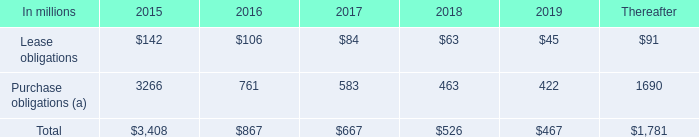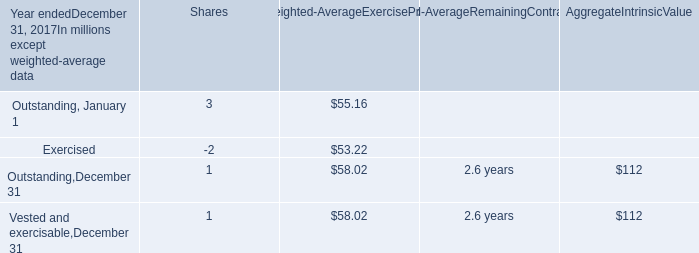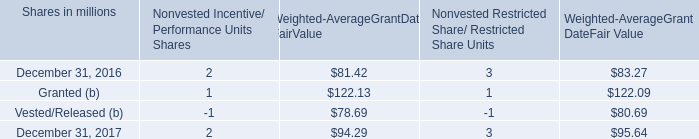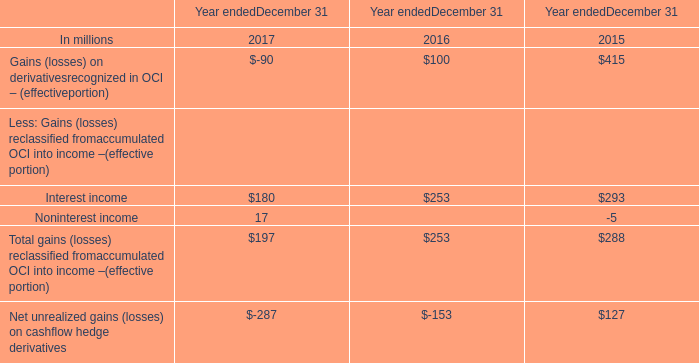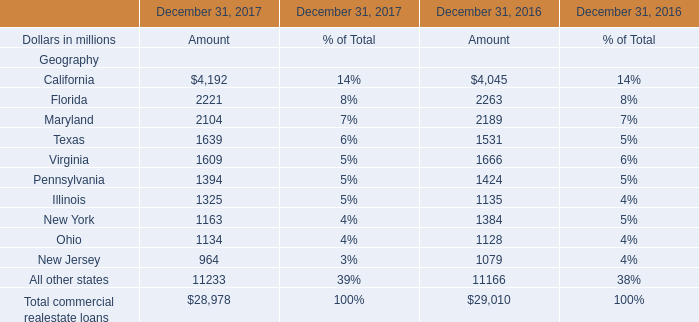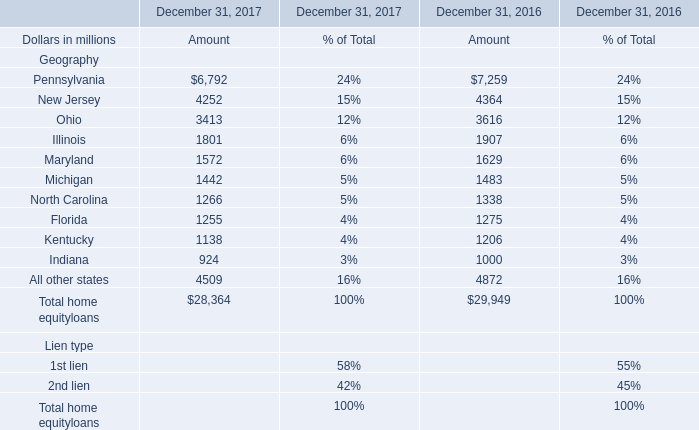What is the proportion of all home equity loans that are greater than 3000 to the total amount of home equity loans, in 2017? (in %) 
Computations: ((((6792 + 4252) + 3413) + 4509) / 28364)
Answer: 0.66866. 